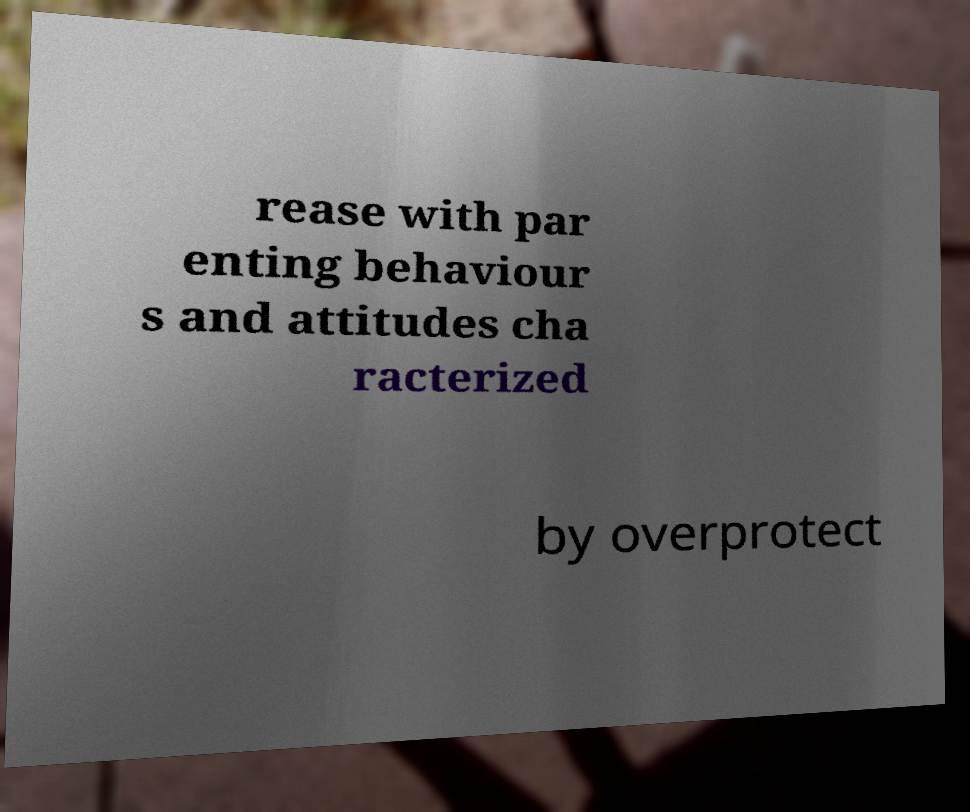For documentation purposes, I need the text within this image transcribed. Could you provide that? rease with par enting behaviour s and attitudes cha racterized by overprotect 